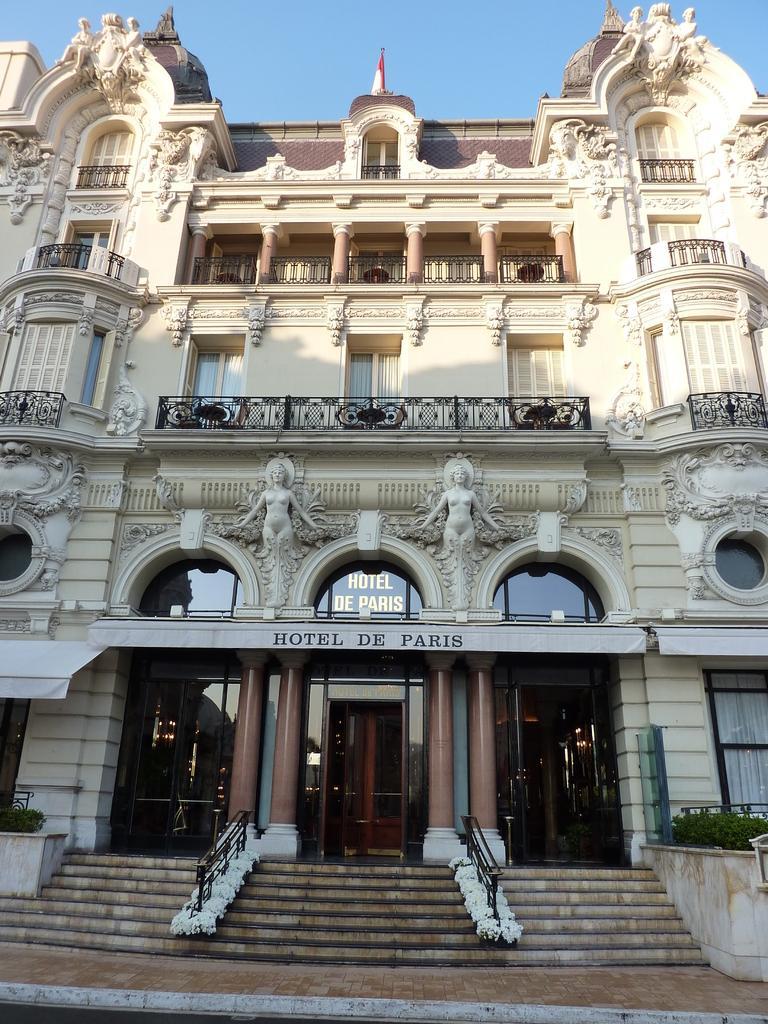Can you describe this image briefly? In the center of the image we can see a building, windows, sculptures on the wall, balconies, pillars, text on the wall. At the bottom of the image we can see the stairs, railing, door, plants, road. At the top of the image we can see the sky and the flag. 